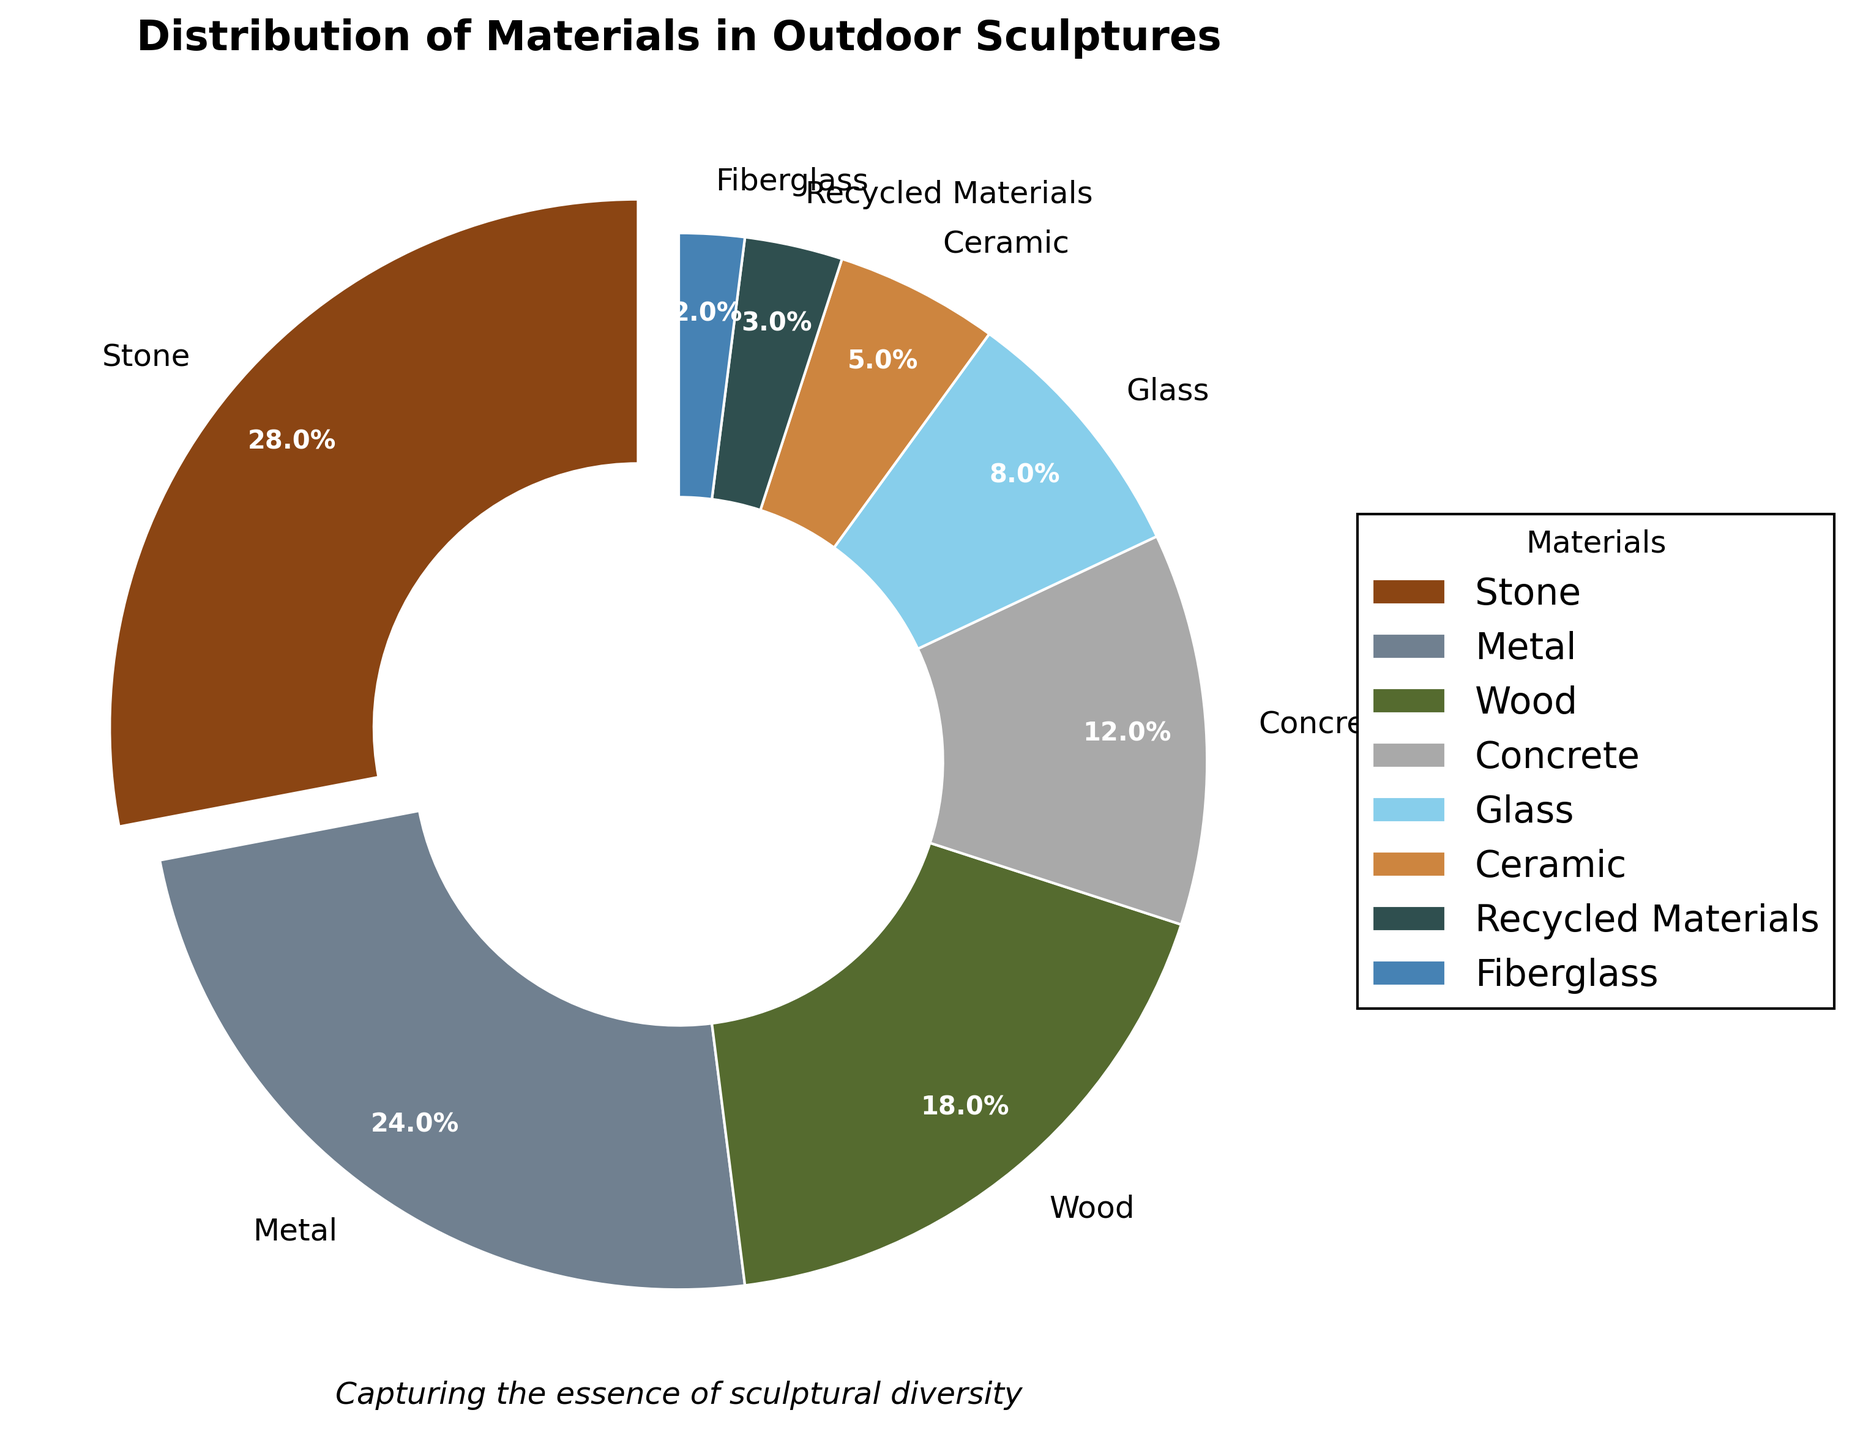Which material is used the most in outdoor sculptures? The material with the highest percentage is used the most. In this case, Stone has the highest percentage at 28%.
Answer: Stone What is the total percentage of the three most used materials? The three most used materials are Stone, Metal, and Wood. Their percentages are 28%, 24%, and 18%, respectively. Summing these: 28 + 24 + 18 = 70%.
Answer: 70% Which material is used less, Glass or Ceramic? Compare the percentages of Glass and Ceramic. Glass has 8% while Ceramic has 5%. Therefore, Ceramic is used less.
Answer: Ceramic How much more popular is Concrete than Recycled Materials? Subtract the percentage of Recycled Materials from Concrete. Concrete is 12% and Recycled Materials is 3%. So, 12 - 3 = 9%.
Answer: 9% What material is represented by the wedge with the light blue color? The light blue color in the pie chart corresponds to Glass.
Answer: Glass What is the combined percentage of materials that compose less than 10% of sculptures? Identify the materials less than 10%: Glass (8%), Ceramic (5%), Recycled Materials (3%), and Fiberglass (2%). Summing these: 8 + 5 + 3 + 2 = 18%.
Answer: 18% Are Ceramic and Fiberglass combined used as much as Metal? Add the percentages of Ceramic and Fiberglass and compare it to Metal. Ceramic (5%) + Fiberglass (2%) = 7%. Metal is 24%, which is greater than 7%.
Answer: No Out of Stone, Metal, and Concrete, which material has the smallest percentage? Compare the percentages of Stone (28%), Metal (24%), and Concrete (12%). Concrete has the smallest percentage.
Answer: Concrete By how much does the percentage of Wood exceed the percentage of Recycled Materials? Subtract the percentage of Recycled Materials from Wood. Wood is 18% and Recycled Materials is 3%. So, 18 - 3 = 15%.
Answer: 15% What is the approximate percentage of materials other than Stone, Metal, and Wood combined? Sum the percentages of materials other than Stone, Metal, and Wood: Concrete (12%), Glass (8%), Ceramic (5%), Recycled Materials (3%), and Fiberglass (2%). Summing these: 12 + 8 + 5 + 3 + 2 = 30%.
Answer: 30% 